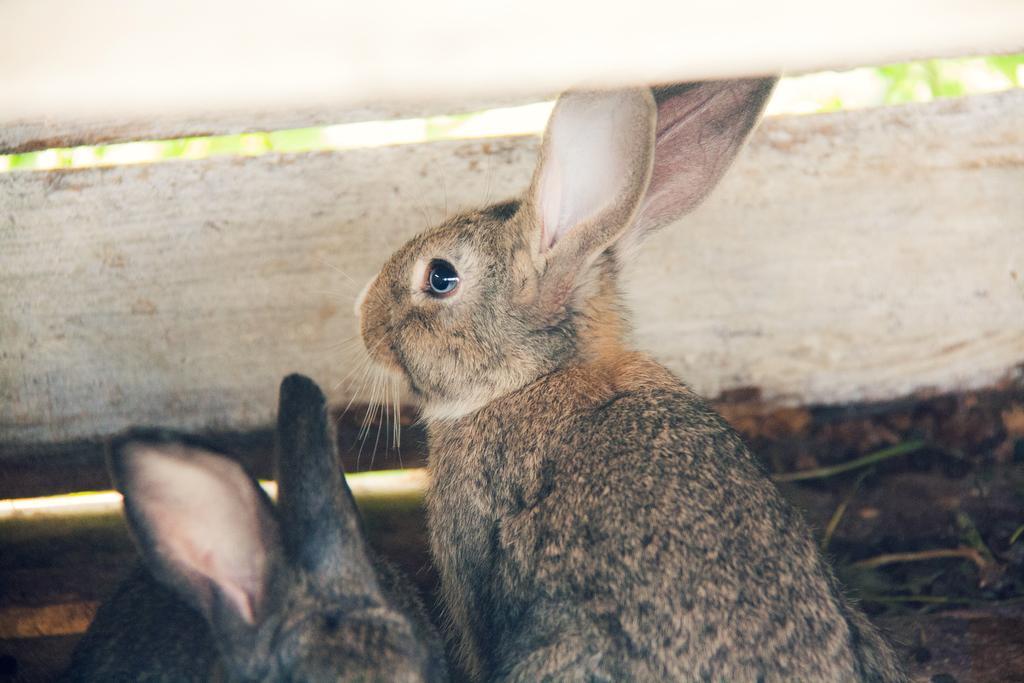Please provide a concise description of this image. In this picture we can see rabbits and blurry background. 